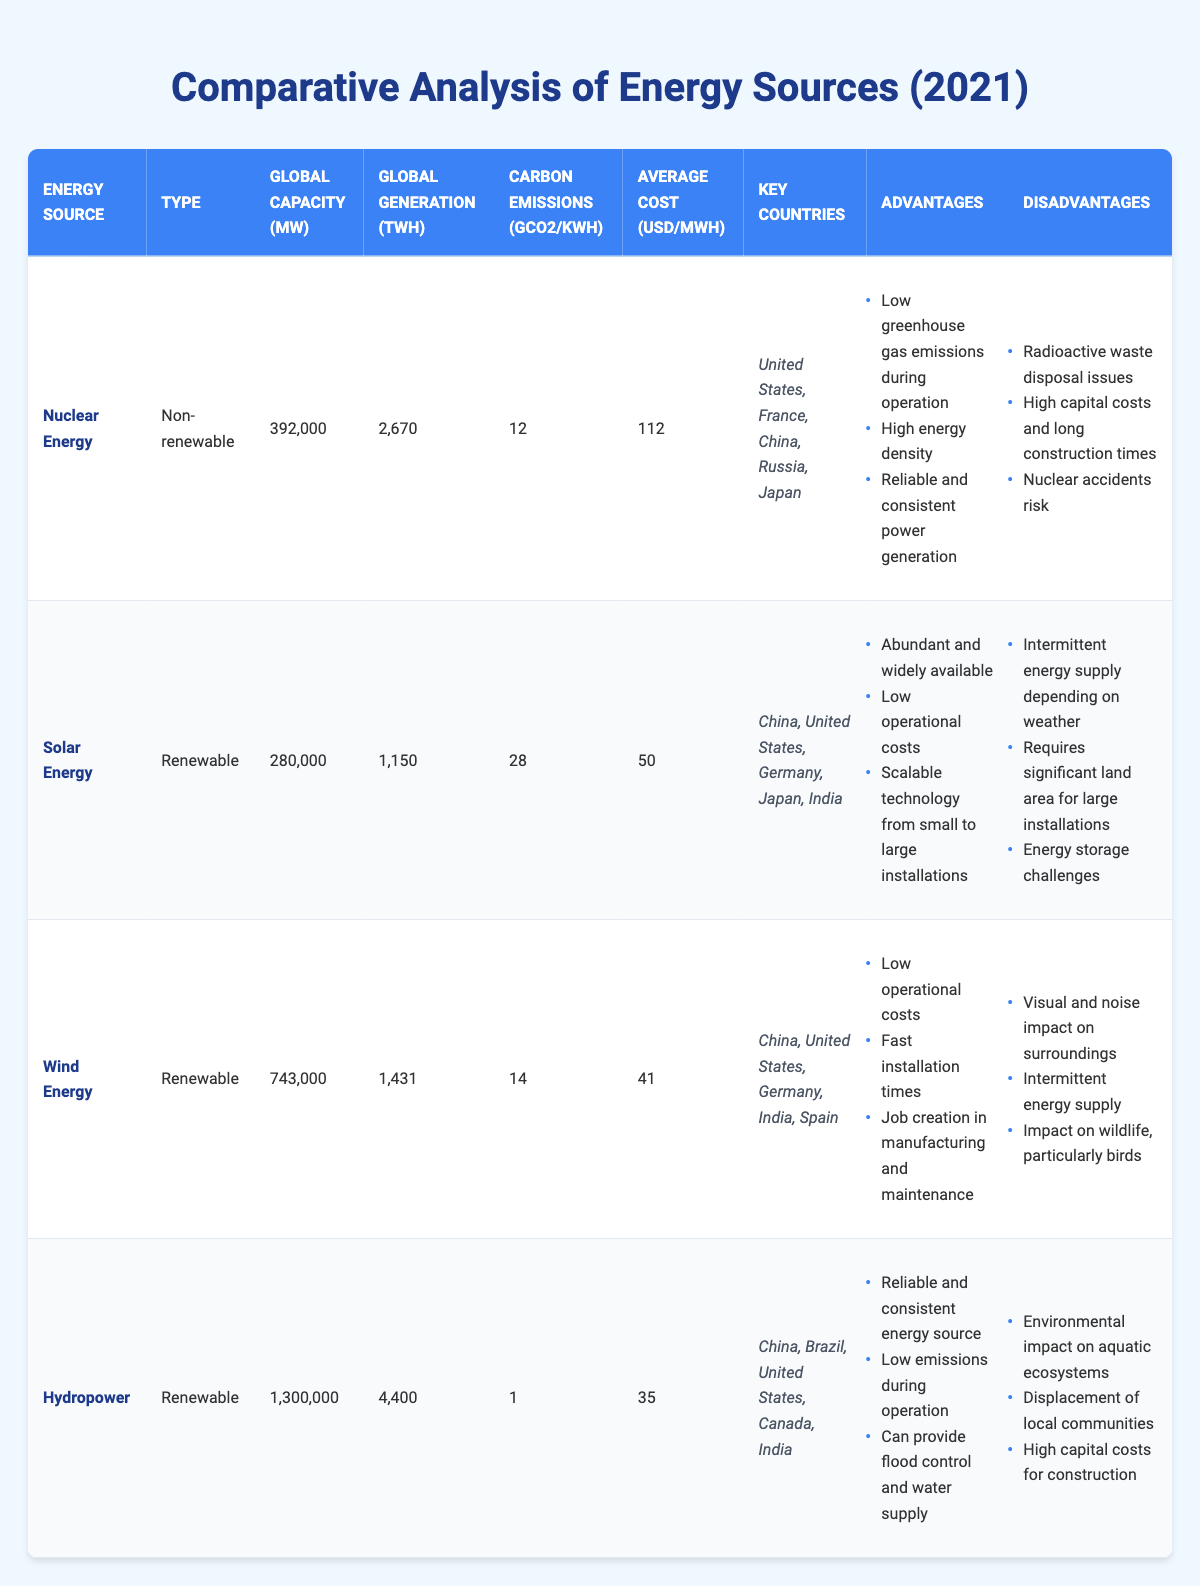What is the global capacity in MW of Hydropower? The table lists the global capacity for Hydropower, which is 1,300,000 MW.
Answer: 1,300,000 MW Which energy source has the lowest carbon emissions per kWh? According to the table, Hydropower has the lowest carbon emissions at 1 gCO2/kWh.
Answer: Hydropower What is the total global generation in TWh from Nuclear Energy and Wind Energy combined? To find the total, we sum their global generation: Nuclear Energy (2,670 TWh) + Wind Energy (1,431 TWh) = 4,101 TWh.
Answer: 4,101 TWh Is the average cost per MWh of Wind Energy higher than that of Solar Energy? The table shows Wind Energy costs 41 USD/MWh while Solar Energy costs 50 USD/MWh. Therefore, the average cost of Wind Energy is not higher than that of Solar Energy.
Answer: No Which renewable energy source has the highest global capacity in MW? The table indicates that Hydropower has the highest capacity at 1,300,000 MW, surpassing all other renewable sources listed.
Answer: Hydropower What is the average carbon emissions per kWh of the three renewable energy sources? For Solar Energy, carbon emissions are 28 gCO2/kWh, Wind Energy is 14 gCO2/kWh, and Hydropower is 1 gCO2/kWh. Therefore, the average is (28 + 14 + 1) / 3 = 14.33 gCO2/kWh.
Answer: 14.33 gCO2/kWh Are the key countries for Nuclear Energy listed in the table all the same as those for Wind Energy? The key countries for Nuclear Energy (United States, France, China, Russia, Japan) are not all the same as those for Wind Energy (China, United States, Germany, India, Spain), thus they are different.
Answer: No What are the disadvantages of Solar Energy listed in the table? The table outlines three disadvantages of Solar Energy: Intermittent energy supply depending on weather, Requires significant land area for large installations, and Energy storage challenges.
Answer: Intermittent supply, land use, storage challenges 